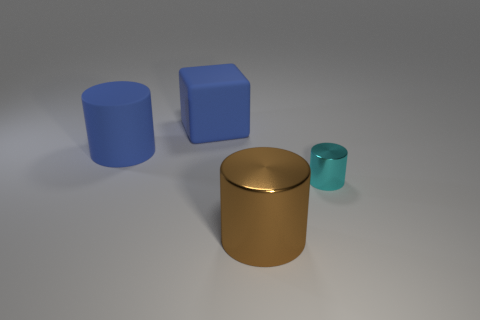Subtract all tiny metallic cylinders. How many cylinders are left? 2 Add 1 things. How many objects exist? 5 Subtract all blocks. How many objects are left? 3 Add 3 tiny objects. How many tiny objects are left? 4 Add 4 large matte cylinders. How many large matte cylinders exist? 5 Subtract 0 yellow spheres. How many objects are left? 4 Subtract all cyan shiny objects. Subtract all matte objects. How many objects are left? 1 